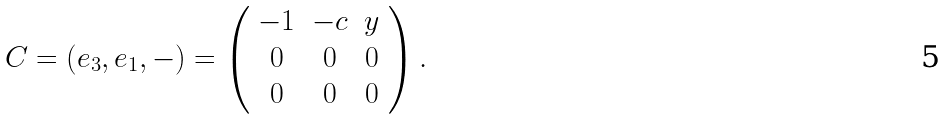Convert formula to latex. <formula><loc_0><loc_0><loc_500><loc_500>C = ( e _ { 3 } , e _ { 1 } , - ) = \left ( \begin{array} { c c c } - 1 & - c & y \\ 0 & 0 & 0 \\ 0 & 0 & 0 \\ \end{array} \right ) .</formula> 